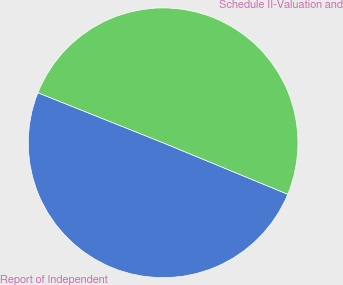Convert chart. <chart><loc_0><loc_0><loc_500><loc_500><pie_chart><fcel>Report of Independent<fcel>Schedule II-Valuation and<nl><fcel>49.82%<fcel>50.18%<nl></chart> 